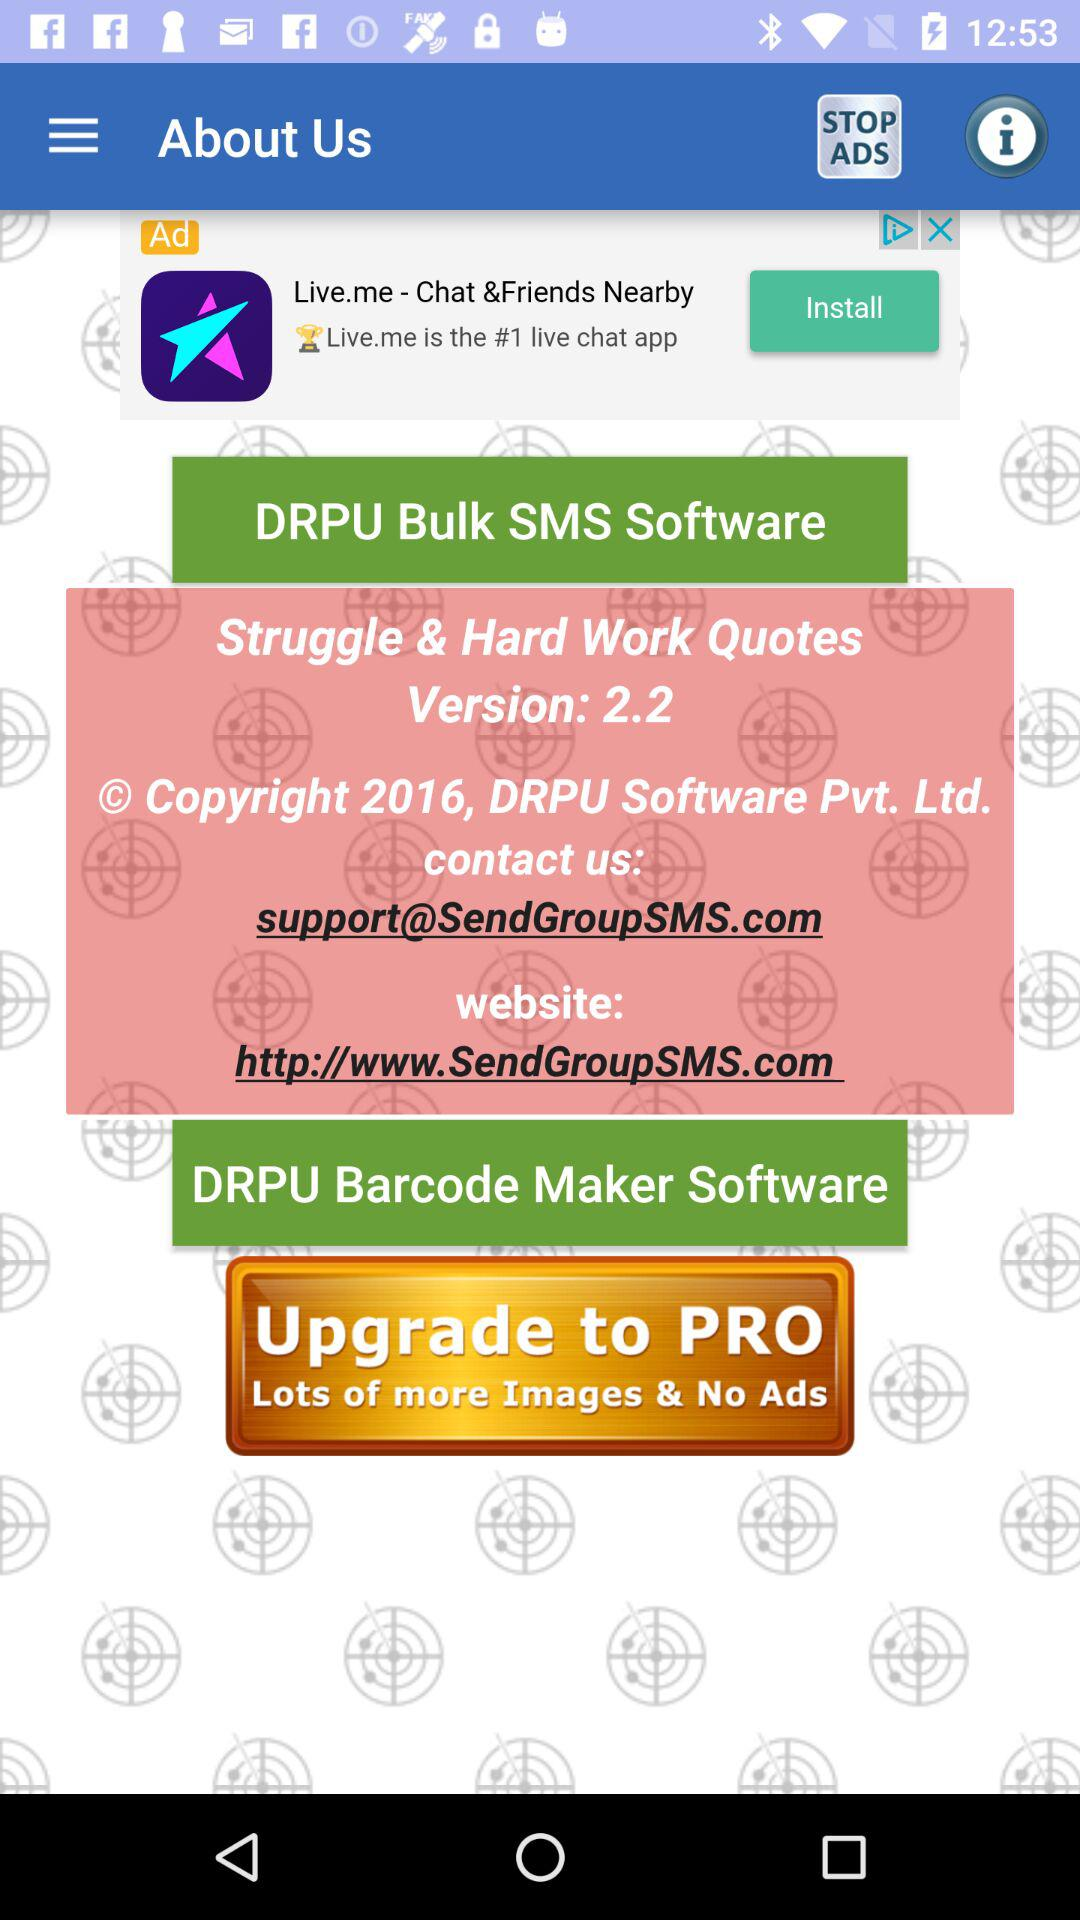What is the website? The website is http://www.SendGroupSMS.com. 